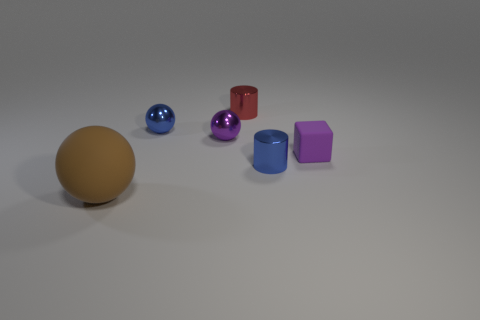What material is the purple object that is the same shape as the brown thing?
Your answer should be very brief. Metal. Are there any other things that are the same size as the purple shiny ball?
Offer a terse response. Yes. There is a object that is to the right of the small blue cylinder; what shape is it?
Your response must be concise. Cube. How many brown matte things are the same shape as the small purple shiny thing?
Offer a terse response. 1. Is the number of purple metallic spheres that are right of the red metal object the same as the number of objects behind the tiny matte thing?
Offer a terse response. No. Is there a yellow object that has the same material as the large sphere?
Give a very brief answer. No. Do the tiny red cylinder and the tiny purple ball have the same material?
Make the answer very short. Yes. What number of blue objects are big spheres or small shiny cylinders?
Offer a very short reply. 1. Are there more big brown spheres behind the small purple shiny sphere than green matte objects?
Your answer should be compact. No. Is there a metallic sphere of the same color as the matte cube?
Offer a very short reply. Yes. 